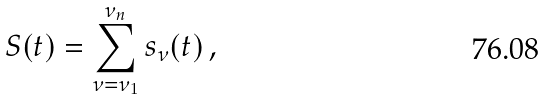<formula> <loc_0><loc_0><loc_500><loc_500>S ( t ) = \sum _ { \nu = \nu _ { 1 } } ^ { \nu _ { n } } s _ { \nu } ( t ) \, ,</formula> 